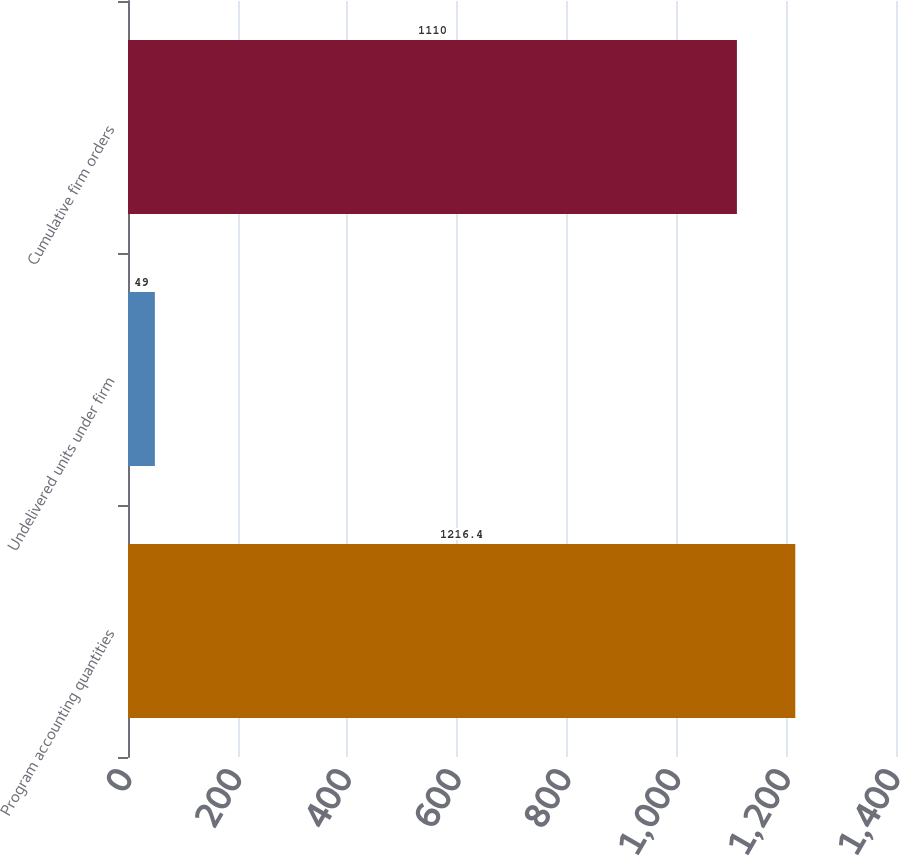<chart> <loc_0><loc_0><loc_500><loc_500><bar_chart><fcel>Program accounting quantities<fcel>Undelivered units under firm<fcel>Cumulative firm orders<nl><fcel>1216.4<fcel>49<fcel>1110<nl></chart> 